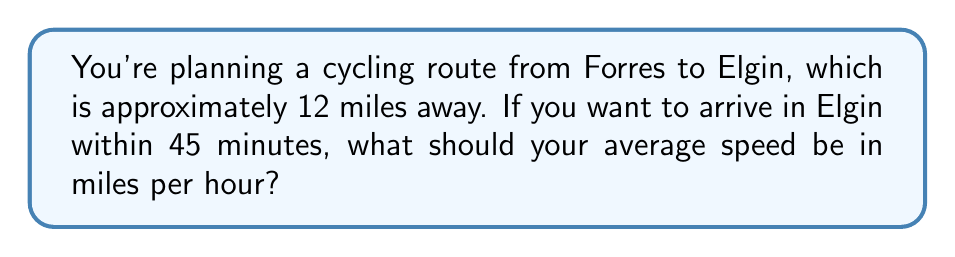Help me with this question. To solve this problem, we need to use the formula for average speed:

$$ \text{Average Speed} = \frac{\text{Distance}}{\text{Time}} $$

Let's break it down step-by-step:

1. We know the distance: 12 miles
2. We know the time: 45 minutes

First, we need to convert 45 minutes to hours:
$$ 45 \text{ minutes} = \frac{45}{60} \text{ hours} = 0.75 \text{ hours} $$

Now we can plug these values into our formula:

$$ \text{Average Speed} = \frac{12 \text{ miles}}{0.75 \text{ hours}} $$

$$ \text{Average Speed} = 16 \text{ miles per hour} $$

Therefore, to cover 12 miles in 45 minutes, you need to maintain an average speed of 16 miles per hour.
Answer: 16 mph 